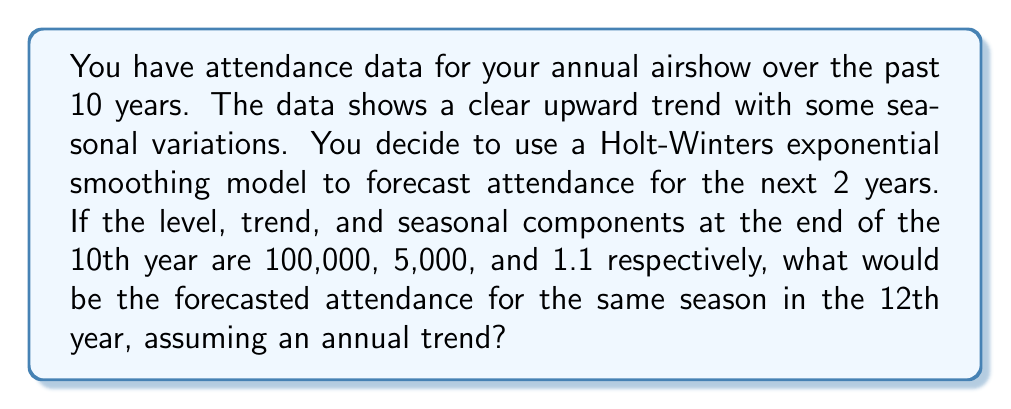Could you help me with this problem? To solve this problem, we'll use the Holt-Winters additive model for forecasting. The formula for this model is:

$$F_{t+h} = (L_t + hT_t)S_{t-s+h}$$

Where:
$F_{t+h}$ is the forecast for h periods ahead
$L_t$ is the level component at time t
$T_t$ is the trend component at time t
$S_t$ is the seasonal component at time t
$s$ is the length of the seasonal cycle
$h$ is the number of periods ahead we're forecasting

Given:
- $L_{10} = 100,000$ (level at end of 10th year)
- $T_{10} = 5,000$ (trend at end of 10th year)
- $S_{10} = 1.1$ (seasonal component for this season)
- We're forecasting 2 years ahead, so $h = 2$
- We're forecasting for the same season, so $S_{t-s+h} = S_{10} = 1.1$

Let's plug these values into the formula:

$$F_{12} = (L_{10} + 2T_{10})S_{10}$$
$$F_{12} = (100,000 + 2(5,000)) * 1.1$$
$$F_{12} = 110,000 * 1.1$$
$$F_{12} = 121,000$$

Therefore, the forecasted attendance for the same season in the 12th year is 121,000.
Answer: 121,000 attendees 